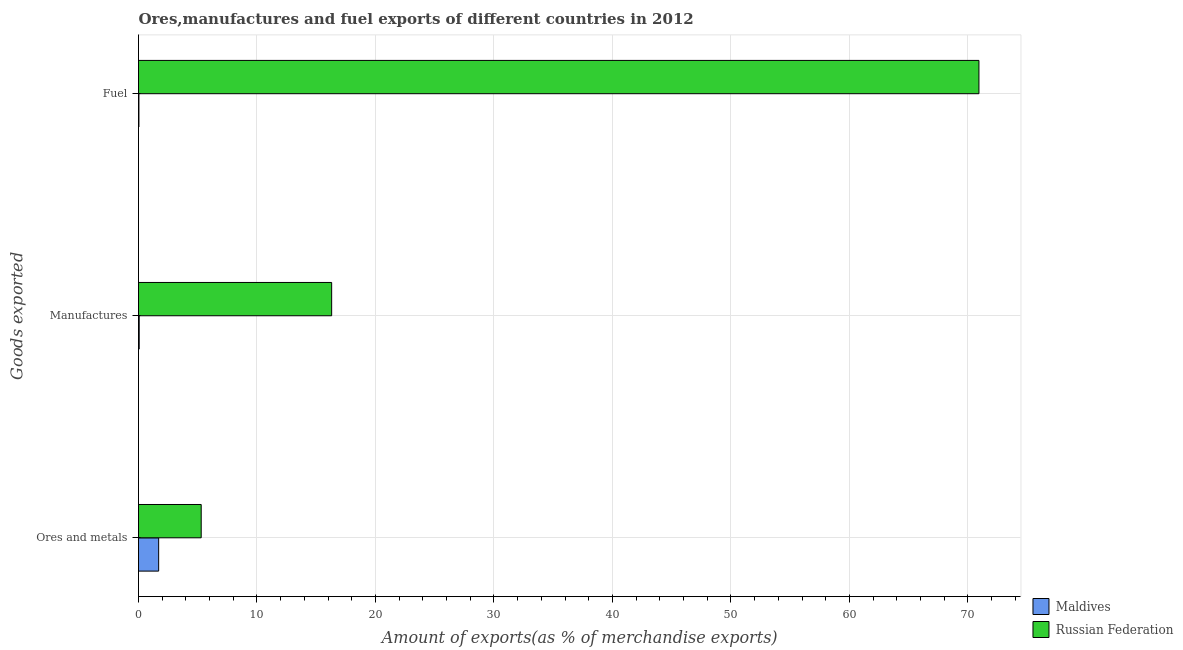How many bars are there on the 2nd tick from the bottom?
Your answer should be compact. 2. What is the label of the 3rd group of bars from the top?
Offer a very short reply. Ores and metals. What is the percentage of fuel exports in Maldives?
Keep it short and to the point. 0.03. Across all countries, what is the maximum percentage of ores and metals exports?
Your response must be concise. 5.29. Across all countries, what is the minimum percentage of ores and metals exports?
Provide a succinct answer. 1.7. In which country was the percentage of fuel exports maximum?
Your answer should be very brief. Russian Federation. In which country was the percentage of fuel exports minimum?
Offer a terse response. Maldives. What is the total percentage of ores and metals exports in the graph?
Offer a terse response. 6.99. What is the difference between the percentage of manufactures exports in Maldives and that in Russian Federation?
Provide a short and direct response. -16.24. What is the difference between the percentage of manufactures exports in Maldives and the percentage of fuel exports in Russian Federation?
Provide a succinct answer. -70.88. What is the average percentage of manufactures exports per country?
Ensure brevity in your answer.  8.18. What is the difference between the percentage of fuel exports and percentage of manufactures exports in Russian Federation?
Make the answer very short. 54.63. What is the ratio of the percentage of manufactures exports in Maldives to that in Russian Federation?
Give a very brief answer. 0. Is the percentage of ores and metals exports in Maldives less than that in Russian Federation?
Your answer should be very brief. Yes. Is the difference between the percentage of fuel exports in Russian Federation and Maldives greater than the difference between the percentage of ores and metals exports in Russian Federation and Maldives?
Offer a very short reply. Yes. What is the difference between the highest and the second highest percentage of manufactures exports?
Ensure brevity in your answer.  16.24. What is the difference between the highest and the lowest percentage of fuel exports?
Your answer should be compact. 70.9. What does the 2nd bar from the top in Ores and metals represents?
Provide a short and direct response. Maldives. What does the 1st bar from the bottom in Ores and metals represents?
Give a very brief answer. Maldives. How many bars are there?
Offer a terse response. 6. Are all the bars in the graph horizontal?
Keep it short and to the point. Yes. How many countries are there in the graph?
Offer a terse response. 2. Are the values on the major ticks of X-axis written in scientific E-notation?
Provide a succinct answer. No. Does the graph contain any zero values?
Your answer should be compact. No. Does the graph contain grids?
Keep it short and to the point. Yes. Where does the legend appear in the graph?
Offer a very short reply. Bottom right. How many legend labels are there?
Your answer should be compact. 2. What is the title of the graph?
Your answer should be compact. Ores,manufactures and fuel exports of different countries in 2012. What is the label or title of the X-axis?
Keep it short and to the point. Amount of exports(as % of merchandise exports). What is the label or title of the Y-axis?
Your answer should be very brief. Goods exported. What is the Amount of exports(as % of merchandise exports) of Maldives in Ores and metals?
Your response must be concise. 1.7. What is the Amount of exports(as % of merchandise exports) in Russian Federation in Ores and metals?
Your answer should be compact. 5.29. What is the Amount of exports(as % of merchandise exports) of Maldives in Manufactures?
Give a very brief answer. 0.06. What is the Amount of exports(as % of merchandise exports) in Russian Federation in Manufactures?
Offer a terse response. 16.3. What is the Amount of exports(as % of merchandise exports) in Maldives in Fuel?
Keep it short and to the point. 0.03. What is the Amount of exports(as % of merchandise exports) in Russian Federation in Fuel?
Offer a very short reply. 70.93. Across all Goods exported, what is the maximum Amount of exports(as % of merchandise exports) in Maldives?
Give a very brief answer. 1.7. Across all Goods exported, what is the maximum Amount of exports(as % of merchandise exports) in Russian Federation?
Your answer should be very brief. 70.93. Across all Goods exported, what is the minimum Amount of exports(as % of merchandise exports) in Maldives?
Ensure brevity in your answer.  0.03. Across all Goods exported, what is the minimum Amount of exports(as % of merchandise exports) in Russian Federation?
Give a very brief answer. 5.29. What is the total Amount of exports(as % of merchandise exports) in Maldives in the graph?
Keep it short and to the point. 1.79. What is the total Amount of exports(as % of merchandise exports) in Russian Federation in the graph?
Your response must be concise. 92.53. What is the difference between the Amount of exports(as % of merchandise exports) of Maldives in Ores and metals and that in Manufactures?
Your answer should be very brief. 1.64. What is the difference between the Amount of exports(as % of merchandise exports) of Russian Federation in Ores and metals and that in Manufactures?
Your answer should be very brief. -11.01. What is the difference between the Amount of exports(as % of merchandise exports) of Maldives in Ores and metals and that in Fuel?
Your response must be concise. 1.67. What is the difference between the Amount of exports(as % of merchandise exports) of Russian Federation in Ores and metals and that in Fuel?
Make the answer very short. -65.64. What is the difference between the Amount of exports(as % of merchandise exports) of Maldives in Manufactures and that in Fuel?
Your response must be concise. 0.02. What is the difference between the Amount of exports(as % of merchandise exports) of Russian Federation in Manufactures and that in Fuel?
Offer a very short reply. -54.63. What is the difference between the Amount of exports(as % of merchandise exports) in Maldives in Ores and metals and the Amount of exports(as % of merchandise exports) in Russian Federation in Manufactures?
Your response must be concise. -14.6. What is the difference between the Amount of exports(as % of merchandise exports) of Maldives in Ores and metals and the Amount of exports(as % of merchandise exports) of Russian Federation in Fuel?
Keep it short and to the point. -69.23. What is the difference between the Amount of exports(as % of merchandise exports) in Maldives in Manufactures and the Amount of exports(as % of merchandise exports) in Russian Federation in Fuel?
Provide a short and direct response. -70.88. What is the average Amount of exports(as % of merchandise exports) of Maldives per Goods exported?
Your answer should be very brief. 0.6. What is the average Amount of exports(as % of merchandise exports) in Russian Federation per Goods exported?
Offer a very short reply. 30.84. What is the difference between the Amount of exports(as % of merchandise exports) of Maldives and Amount of exports(as % of merchandise exports) of Russian Federation in Ores and metals?
Offer a very short reply. -3.59. What is the difference between the Amount of exports(as % of merchandise exports) in Maldives and Amount of exports(as % of merchandise exports) in Russian Federation in Manufactures?
Ensure brevity in your answer.  -16.24. What is the difference between the Amount of exports(as % of merchandise exports) in Maldives and Amount of exports(as % of merchandise exports) in Russian Federation in Fuel?
Offer a very short reply. -70.9. What is the ratio of the Amount of exports(as % of merchandise exports) in Maldives in Ores and metals to that in Manufactures?
Ensure brevity in your answer.  29.32. What is the ratio of the Amount of exports(as % of merchandise exports) in Russian Federation in Ores and metals to that in Manufactures?
Make the answer very short. 0.32. What is the ratio of the Amount of exports(as % of merchandise exports) of Maldives in Ores and metals to that in Fuel?
Offer a very short reply. 49.57. What is the ratio of the Amount of exports(as % of merchandise exports) of Russian Federation in Ores and metals to that in Fuel?
Your answer should be compact. 0.07. What is the ratio of the Amount of exports(as % of merchandise exports) in Maldives in Manufactures to that in Fuel?
Offer a terse response. 1.69. What is the ratio of the Amount of exports(as % of merchandise exports) of Russian Federation in Manufactures to that in Fuel?
Offer a terse response. 0.23. What is the difference between the highest and the second highest Amount of exports(as % of merchandise exports) in Maldives?
Your answer should be compact. 1.64. What is the difference between the highest and the second highest Amount of exports(as % of merchandise exports) of Russian Federation?
Offer a very short reply. 54.63. What is the difference between the highest and the lowest Amount of exports(as % of merchandise exports) of Maldives?
Make the answer very short. 1.67. What is the difference between the highest and the lowest Amount of exports(as % of merchandise exports) in Russian Federation?
Your response must be concise. 65.64. 